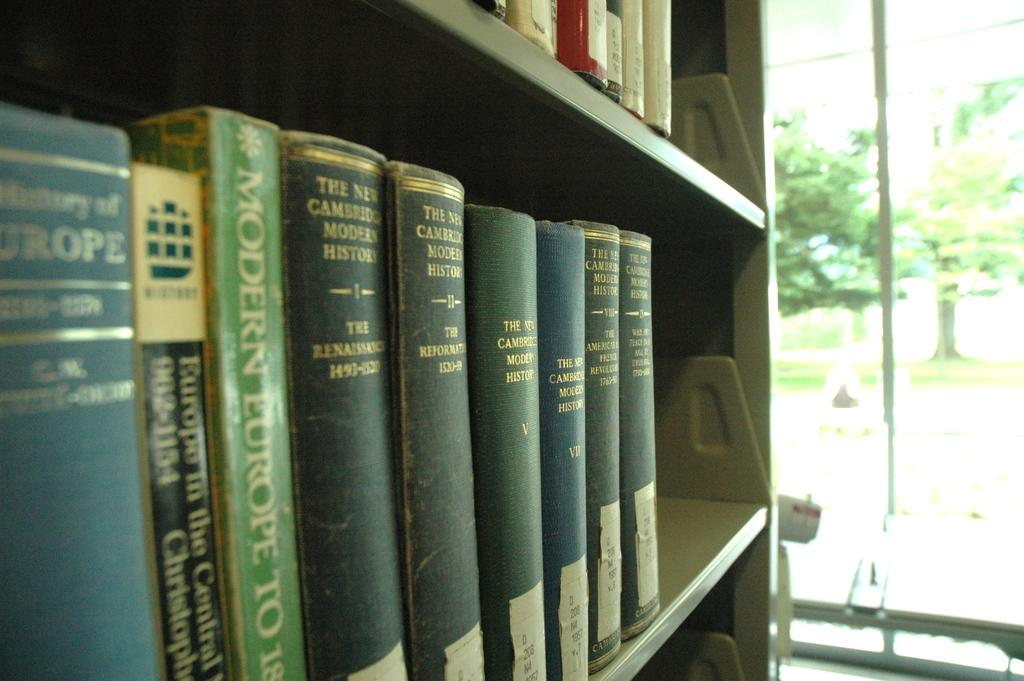Provide a one-sentence caption for the provided image. Blue and green colored books are on a bookshelf in a room. 